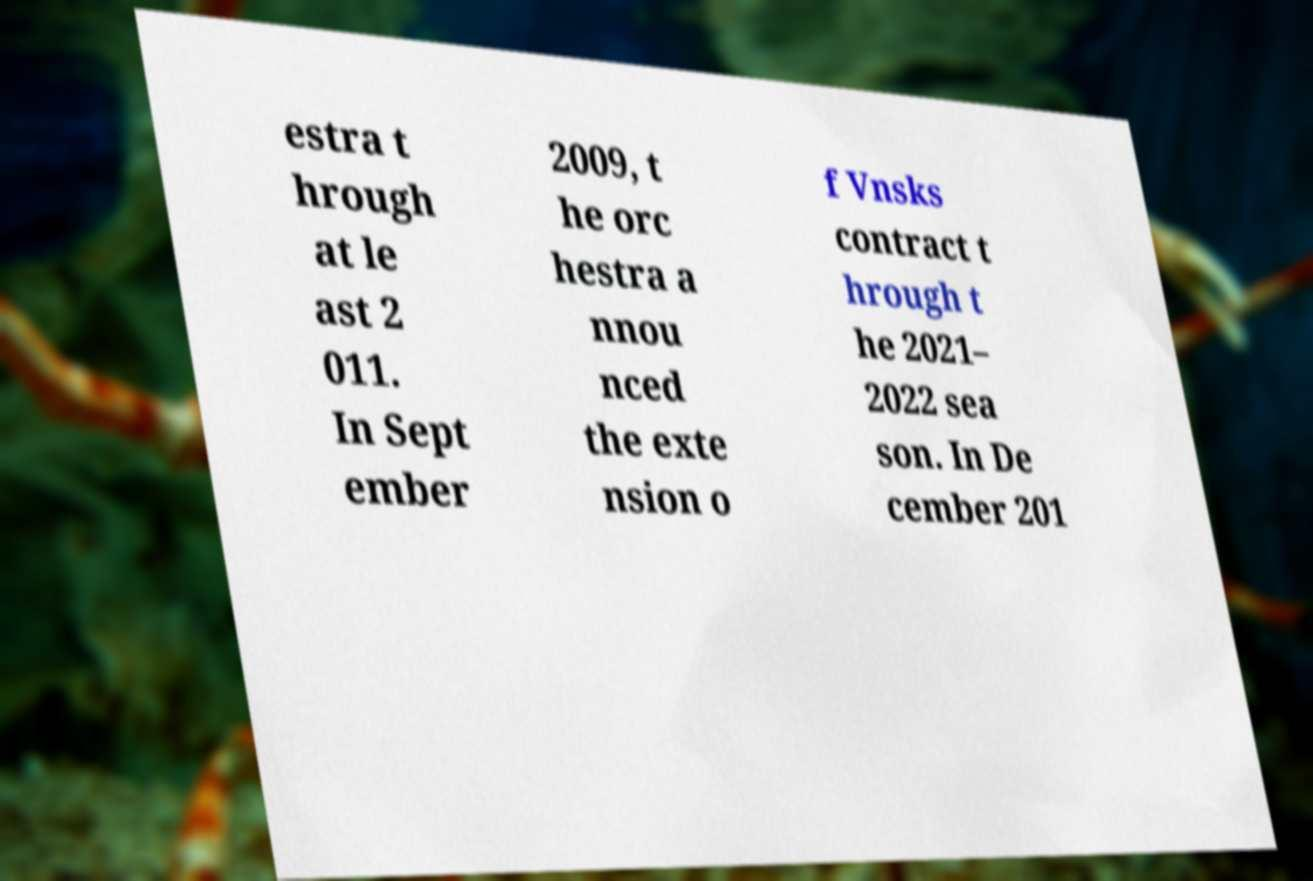Can you accurately transcribe the text from the provided image for me? estra t hrough at le ast 2 011. In Sept ember 2009, t he orc hestra a nnou nced the exte nsion o f Vnsks contract t hrough t he 2021– 2022 sea son. In De cember 201 